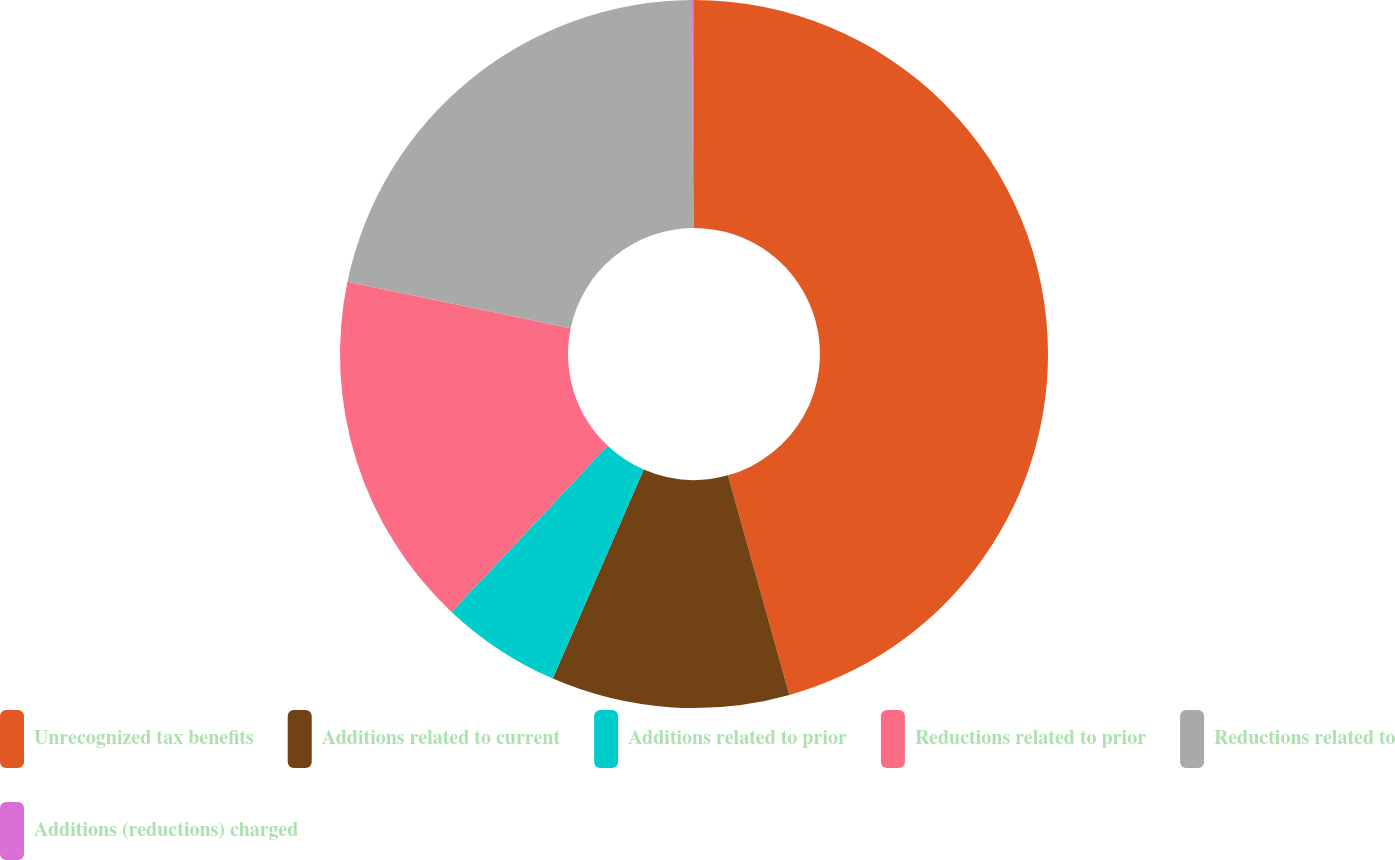Convert chart. <chart><loc_0><loc_0><loc_500><loc_500><pie_chart><fcel>Unrecognized tax benefits<fcel>Additions related to current<fcel>Additions related to prior<fcel>Reductions related to prior<fcel>Reductions related to<fcel>Additions (reductions) charged<nl><fcel>45.66%<fcel>10.87%<fcel>5.48%<fcel>16.26%<fcel>21.64%<fcel>0.09%<nl></chart> 